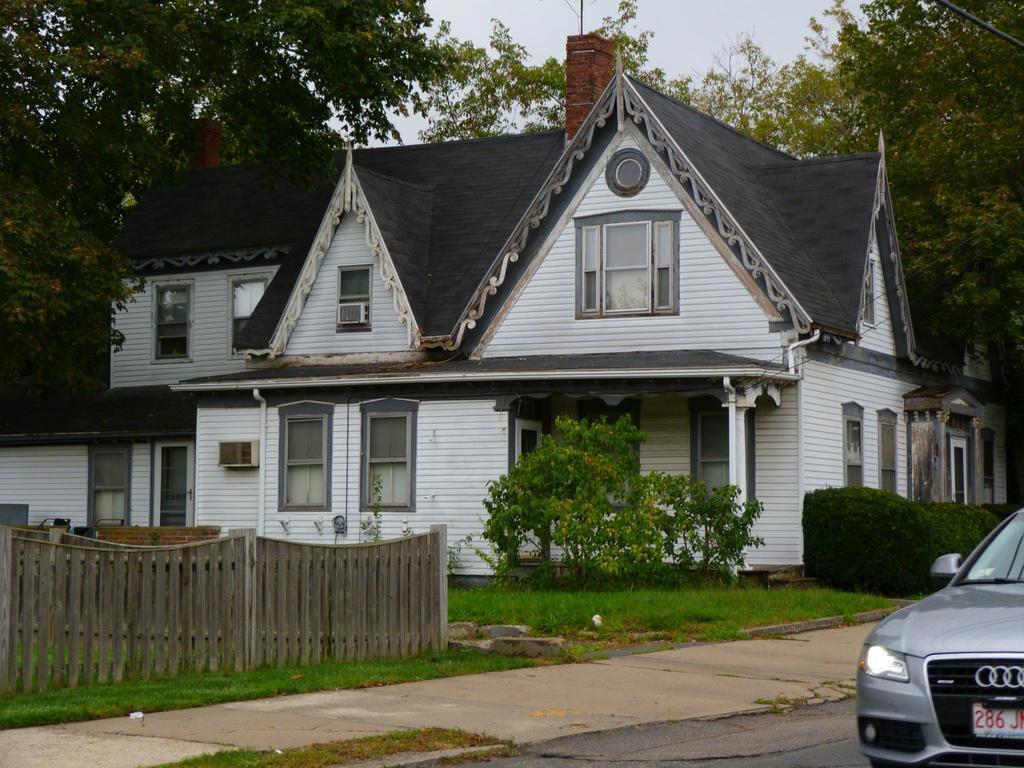Can you describe this image briefly? There is a car and a wooden boundary in the foreground area of the image, there are plants, trees, house and the sky in the background. 